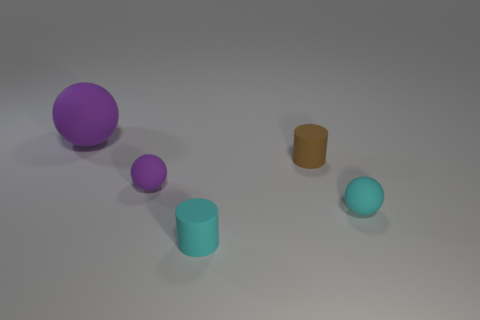What can you infer about the lighting in this scene? The lighting appears to be coming from the upper left side, as suggested by the shadows cast on the right sides of the objects, which creates a calm and evenly lit scene. Is there anything notable about the surface the objects are resting on? Indeed, the surface is smooth with a matte finish, which softly reflects some of the light, bringing a subtle realism to the environment. 